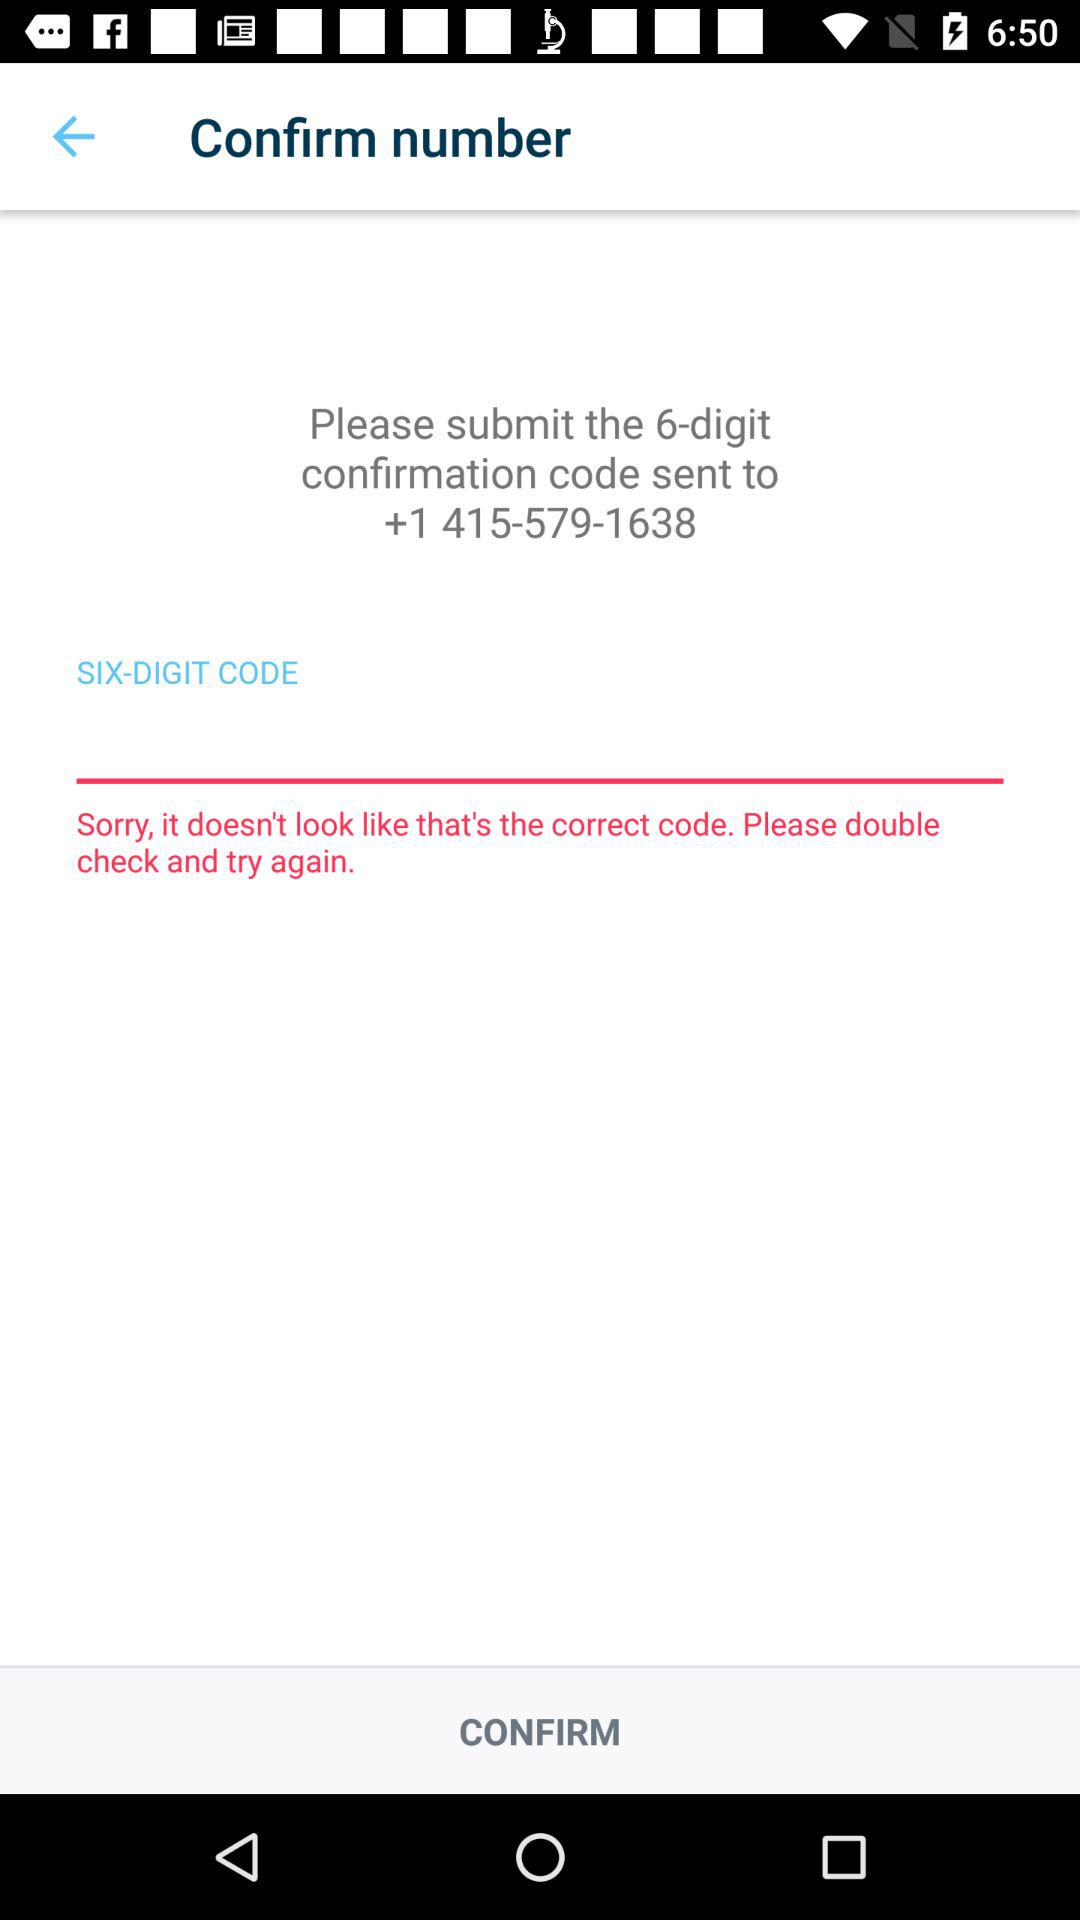What will be number of digit code sent to the contact number? The number will be 6. 